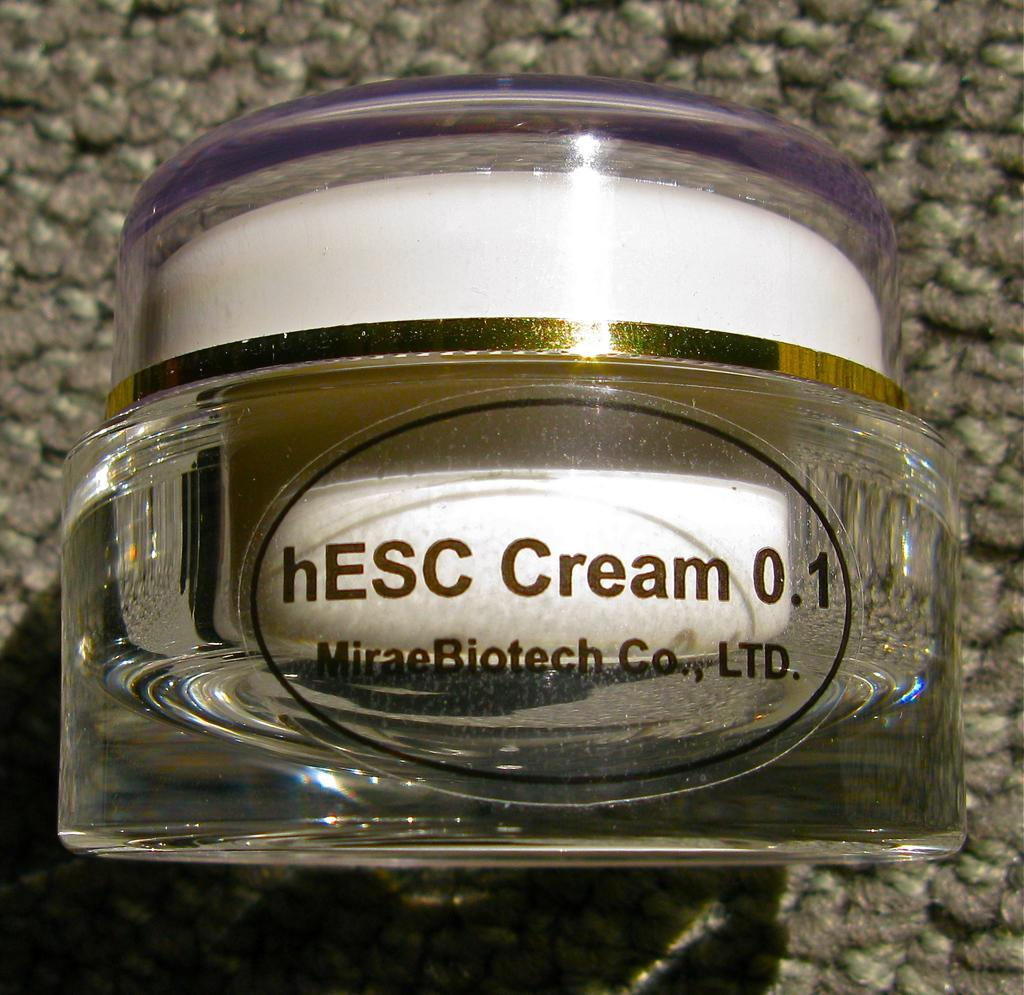<image>
Present a compact description of the photo's key features. A cream inside of a glass container made by MiraeBiotech. 